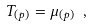<formula> <loc_0><loc_0><loc_500><loc_500>T _ { ( p ) } = \mu _ { ( p ) } \ ,</formula> 